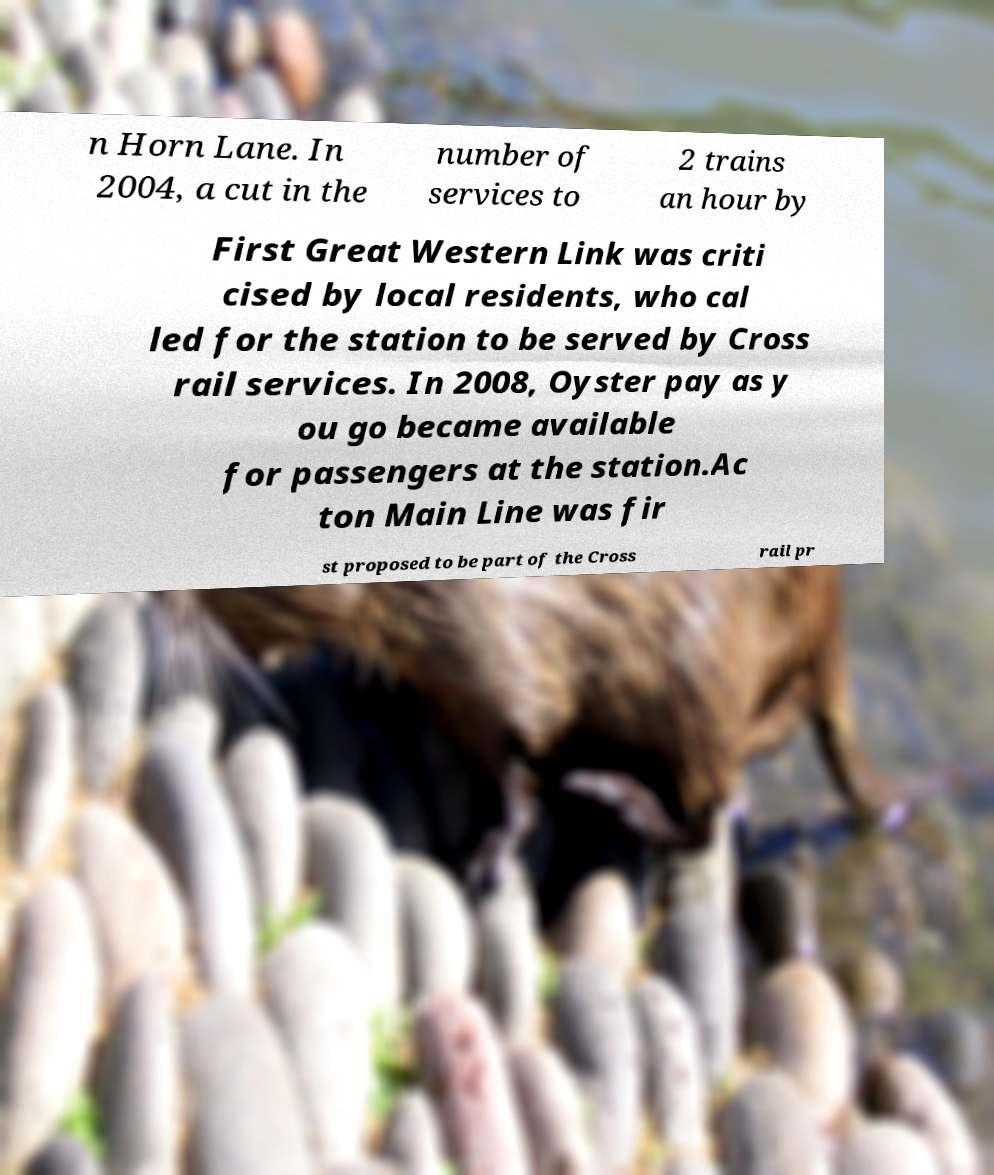Can you accurately transcribe the text from the provided image for me? n Horn Lane. In 2004, a cut in the number of services to 2 trains an hour by First Great Western Link was criti cised by local residents, who cal led for the station to be served by Cross rail services. In 2008, Oyster pay as y ou go became available for passengers at the station.Ac ton Main Line was fir st proposed to be part of the Cross rail pr 